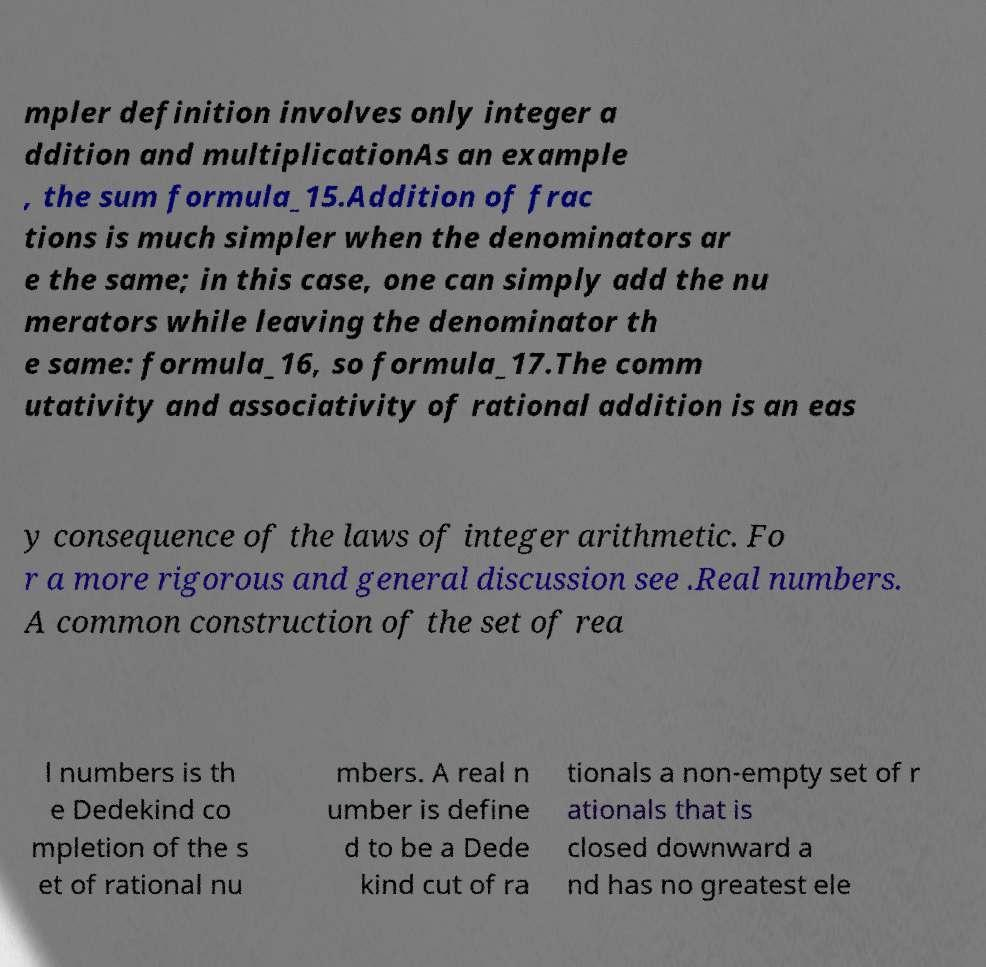Could you assist in decoding the text presented in this image and type it out clearly? mpler definition involves only integer a ddition and multiplicationAs an example , the sum formula_15.Addition of frac tions is much simpler when the denominators ar e the same; in this case, one can simply add the nu merators while leaving the denominator th e same: formula_16, so formula_17.The comm utativity and associativity of rational addition is an eas y consequence of the laws of integer arithmetic. Fo r a more rigorous and general discussion see .Real numbers. A common construction of the set of rea l numbers is th e Dedekind co mpletion of the s et of rational nu mbers. A real n umber is define d to be a Dede kind cut of ra tionals a non-empty set of r ationals that is closed downward a nd has no greatest ele 